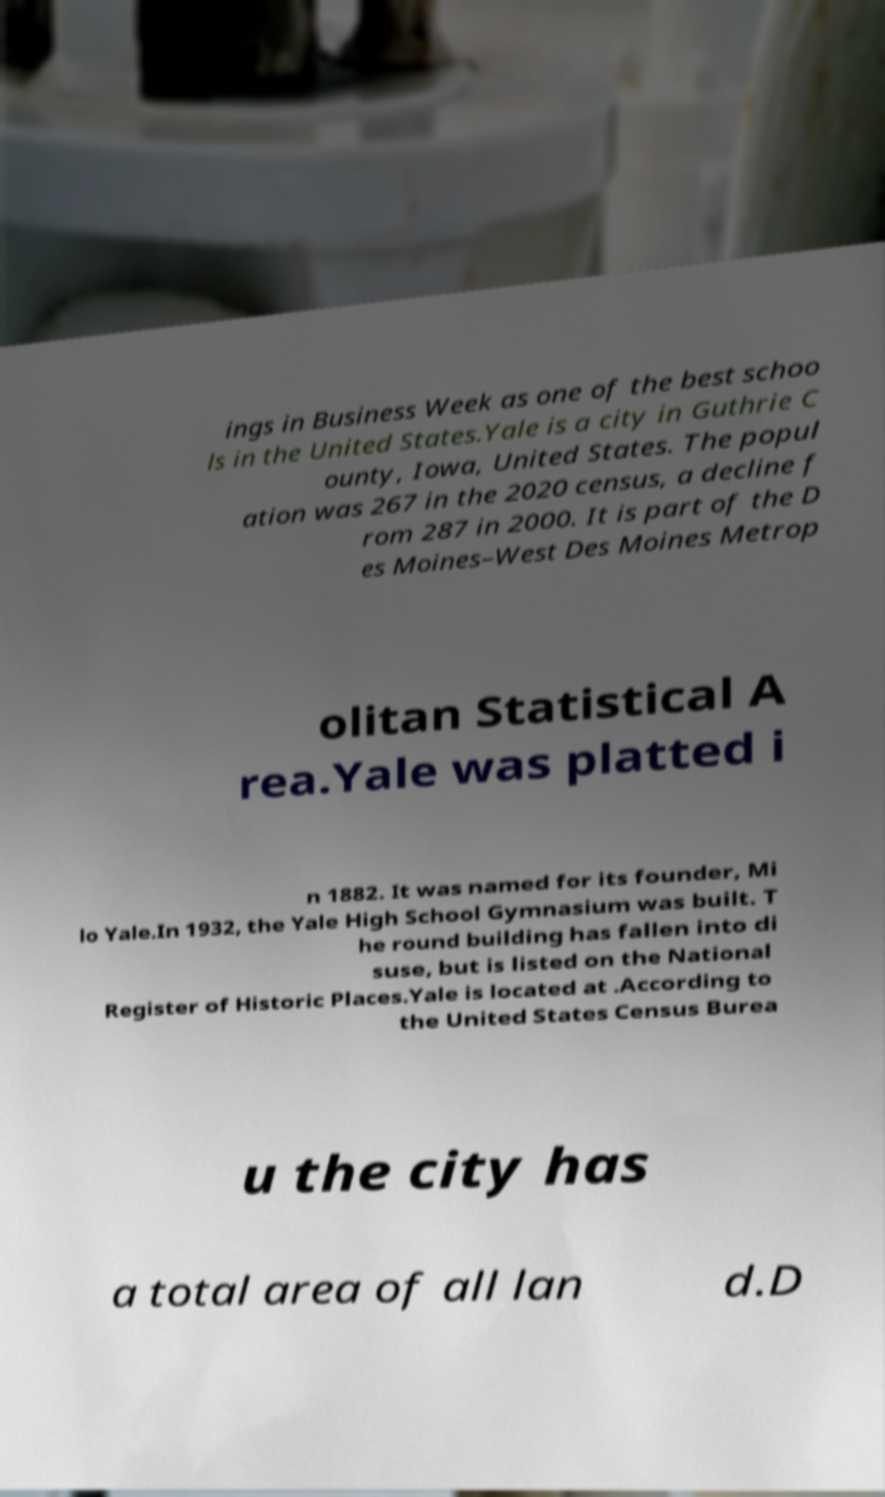Can you read and provide the text displayed in the image?This photo seems to have some interesting text. Can you extract and type it out for me? ings in Business Week as one of the best schoo ls in the United States.Yale is a city in Guthrie C ounty, Iowa, United States. The popul ation was 267 in the 2020 census, a decline f rom 287 in 2000. It is part of the D es Moines–West Des Moines Metrop olitan Statistical A rea.Yale was platted i n 1882. It was named for its founder, Mi lo Yale.In 1932, the Yale High School Gymnasium was built. T he round building has fallen into di suse, but is listed on the National Register of Historic Places.Yale is located at .According to the United States Census Burea u the city has a total area of all lan d.D 